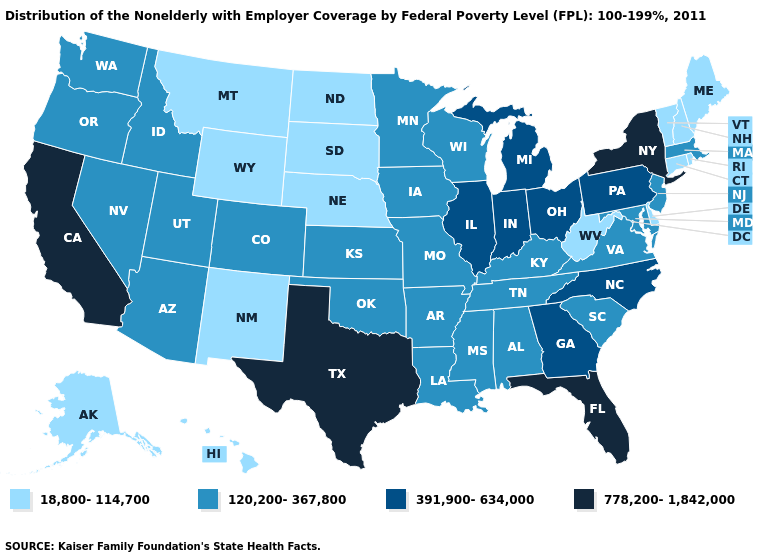Among the states that border Vermont , does New Hampshire have the lowest value?
Give a very brief answer. Yes. Does Florida have the highest value in the USA?
Quick response, please. Yes. What is the value of Illinois?
Give a very brief answer. 391,900-634,000. What is the value of Texas?
Concise answer only. 778,200-1,842,000. Does Missouri have the same value as Alaska?
Quick response, please. No. What is the lowest value in the South?
Write a very short answer. 18,800-114,700. Does Idaho have a higher value than Nebraska?
Short answer required. Yes. What is the lowest value in the MidWest?
Write a very short answer. 18,800-114,700. Is the legend a continuous bar?
Answer briefly. No. What is the value of Vermont?
Write a very short answer. 18,800-114,700. Is the legend a continuous bar?
Answer briefly. No. What is the value of Arizona?
Give a very brief answer. 120,200-367,800. Name the states that have a value in the range 778,200-1,842,000?
Short answer required. California, Florida, New York, Texas. Name the states that have a value in the range 120,200-367,800?
Quick response, please. Alabama, Arizona, Arkansas, Colorado, Idaho, Iowa, Kansas, Kentucky, Louisiana, Maryland, Massachusetts, Minnesota, Mississippi, Missouri, Nevada, New Jersey, Oklahoma, Oregon, South Carolina, Tennessee, Utah, Virginia, Washington, Wisconsin. What is the value of Arizona?
Be succinct. 120,200-367,800. 